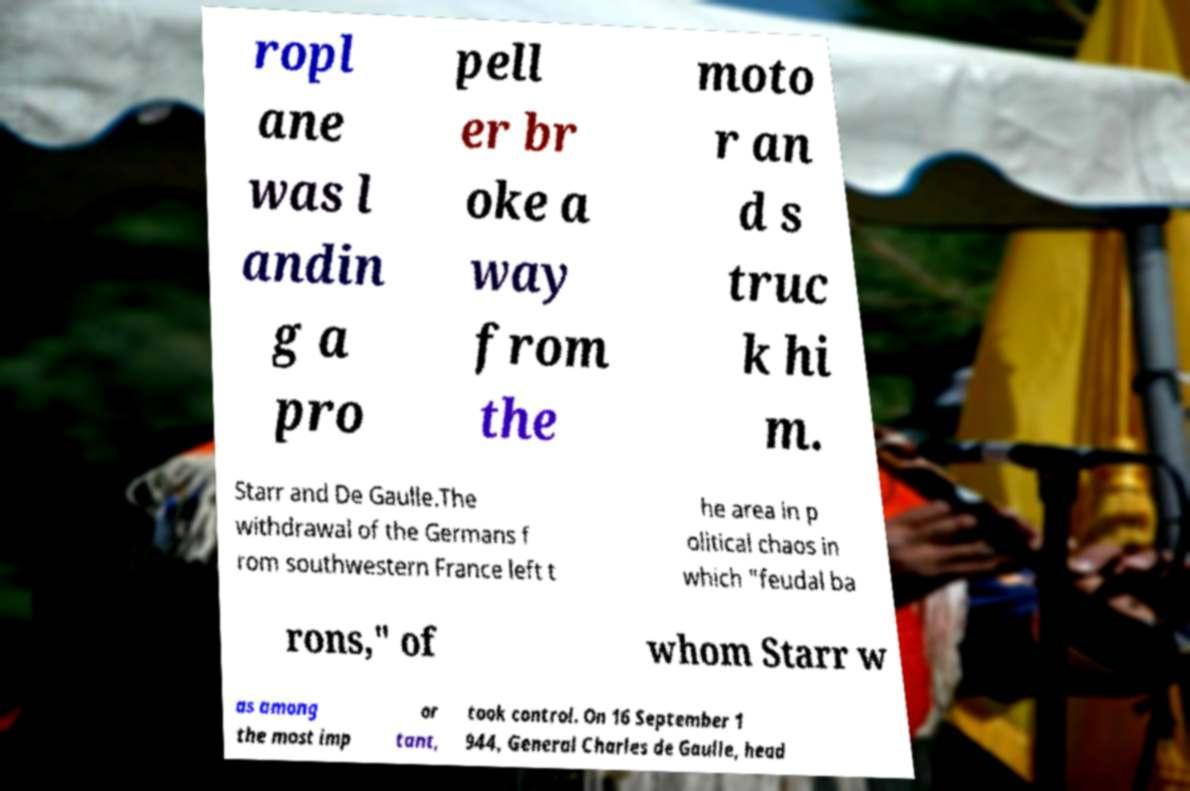Please read and relay the text visible in this image. What does it say? ropl ane was l andin g a pro pell er br oke a way from the moto r an d s truc k hi m. Starr and De Gaulle.The withdrawal of the Germans f rom southwestern France left t he area in p olitical chaos in which "feudal ba rons," of whom Starr w as among the most imp or tant, took control. On 16 September 1 944, General Charles de Gaulle, head 